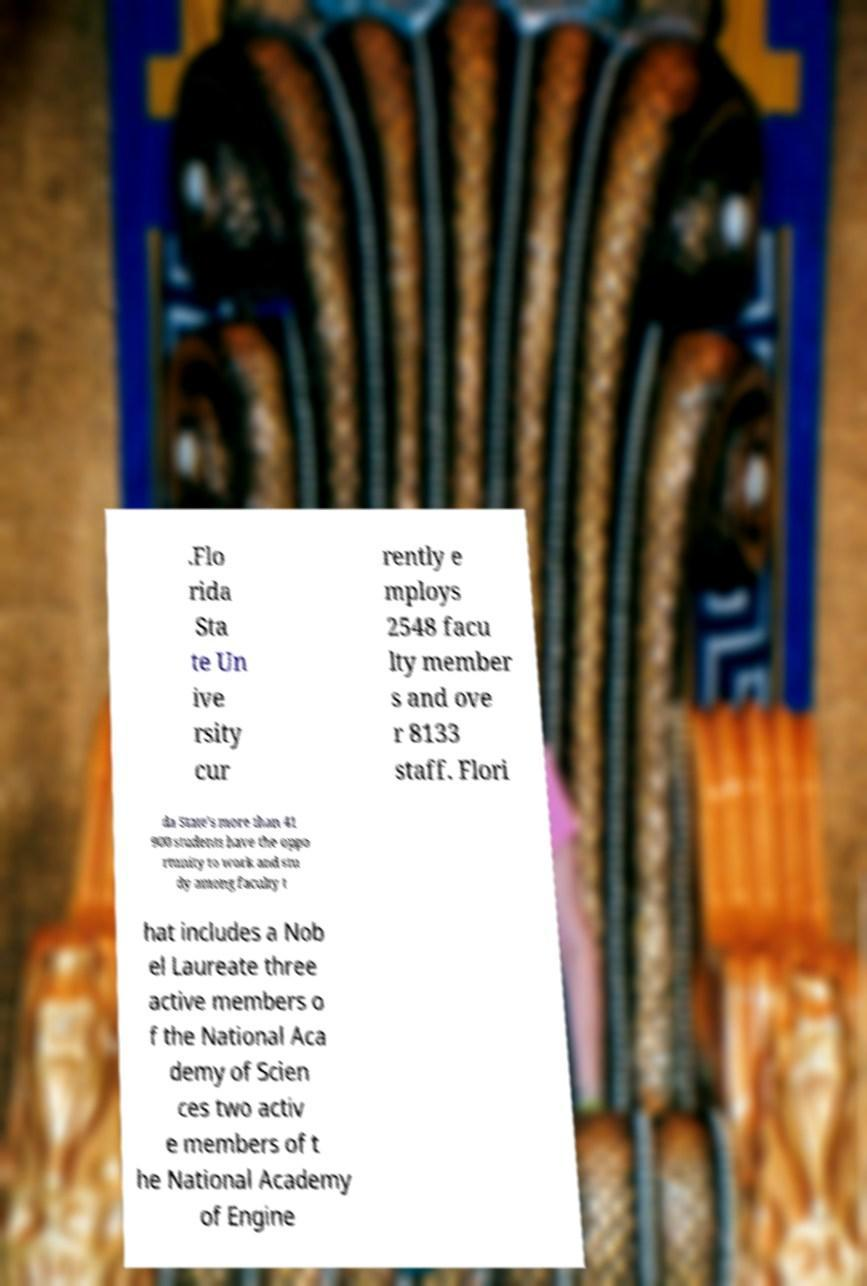Can you accurately transcribe the text from the provided image for me? .Flo rida Sta te Un ive rsity cur rently e mploys 2548 facu lty member s and ove r 8133 staff. Flori da State's more than 41 900 students have the oppo rtunity to work and stu dy among faculty t hat includes a Nob el Laureate three active members o f the National Aca demy of Scien ces two activ e members of t he National Academy of Engine 